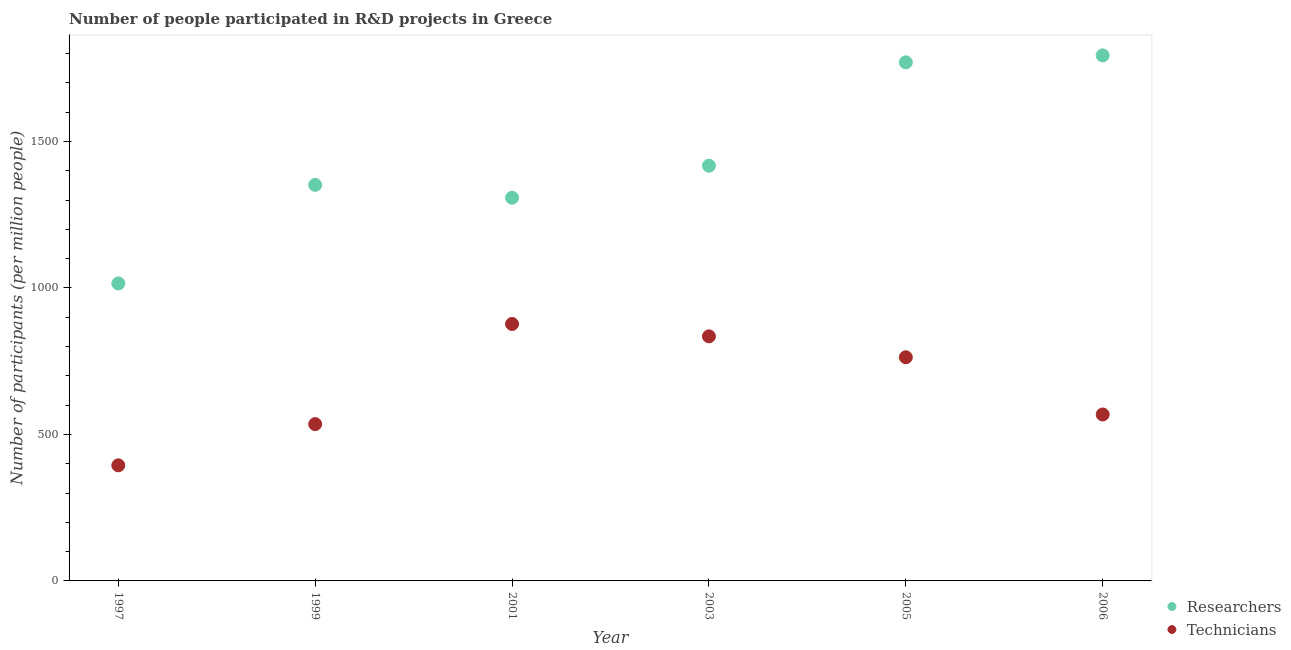Is the number of dotlines equal to the number of legend labels?
Your answer should be very brief. Yes. What is the number of researchers in 2001?
Give a very brief answer. 1307.94. Across all years, what is the maximum number of technicians?
Provide a short and direct response. 877.01. Across all years, what is the minimum number of researchers?
Provide a short and direct response. 1015.39. In which year was the number of researchers maximum?
Your answer should be compact. 2006. What is the total number of technicians in the graph?
Offer a terse response. 3972.89. What is the difference between the number of researchers in 1997 and that in 1999?
Make the answer very short. -336.27. What is the difference between the number of researchers in 2001 and the number of technicians in 1999?
Your answer should be compact. 772.8. What is the average number of technicians per year?
Your answer should be very brief. 662.15. In the year 1997, what is the difference between the number of technicians and number of researchers?
Keep it short and to the point. -620.87. What is the ratio of the number of technicians in 2005 to that in 2006?
Give a very brief answer. 1.34. What is the difference between the highest and the second highest number of researchers?
Provide a succinct answer. 23.75. What is the difference between the highest and the lowest number of researchers?
Your answer should be compact. 778.31. In how many years, is the number of technicians greater than the average number of technicians taken over all years?
Your answer should be compact. 3. Is the sum of the number of researchers in 2001 and 2005 greater than the maximum number of technicians across all years?
Your response must be concise. Yes. How many dotlines are there?
Your answer should be very brief. 2. Are the values on the major ticks of Y-axis written in scientific E-notation?
Your response must be concise. No. Does the graph contain any zero values?
Ensure brevity in your answer.  No. How many legend labels are there?
Make the answer very short. 2. What is the title of the graph?
Ensure brevity in your answer.  Number of people participated in R&D projects in Greece. Does "Secondary Education" appear as one of the legend labels in the graph?
Offer a terse response. No. What is the label or title of the X-axis?
Your answer should be very brief. Year. What is the label or title of the Y-axis?
Your response must be concise. Number of participants (per million people). What is the Number of participants (per million people) in Researchers in 1997?
Make the answer very short. 1015.39. What is the Number of participants (per million people) in Technicians in 1997?
Your answer should be compact. 394.52. What is the Number of participants (per million people) in Researchers in 1999?
Offer a terse response. 1351.66. What is the Number of participants (per million people) in Technicians in 1999?
Make the answer very short. 535.14. What is the Number of participants (per million people) of Researchers in 2001?
Your answer should be very brief. 1307.94. What is the Number of participants (per million people) of Technicians in 2001?
Your answer should be compact. 877.01. What is the Number of participants (per million people) of Researchers in 2003?
Give a very brief answer. 1417.21. What is the Number of participants (per million people) of Technicians in 2003?
Provide a succinct answer. 834.74. What is the Number of participants (per million people) of Researchers in 2005?
Ensure brevity in your answer.  1769.95. What is the Number of participants (per million people) in Technicians in 2005?
Your response must be concise. 763.38. What is the Number of participants (per million people) of Researchers in 2006?
Provide a succinct answer. 1793.7. What is the Number of participants (per million people) in Technicians in 2006?
Offer a very short reply. 568.1. Across all years, what is the maximum Number of participants (per million people) of Researchers?
Provide a succinct answer. 1793.7. Across all years, what is the maximum Number of participants (per million people) of Technicians?
Your answer should be very brief. 877.01. Across all years, what is the minimum Number of participants (per million people) in Researchers?
Provide a short and direct response. 1015.39. Across all years, what is the minimum Number of participants (per million people) in Technicians?
Your answer should be very brief. 394.52. What is the total Number of participants (per million people) of Researchers in the graph?
Your answer should be very brief. 8655.87. What is the total Number of participants (per million people) in Technicians in the graph?
Your answer should be very brief. 3972.89. What is the difference between the Number of participants (per million people) of Researchers in 1997 and that in 1999?
Give a very brief answer. -336.27. What is the difference between the Number of participants (per million people) of Technicians in 1997 and that in 1999?
Your answer should be compact. -140.62. What is the difference between the Number of participants (per million people) in Researchers in 1997 and that in 2001?
Your answer should be very brief. -292.55. What is the difference between the Number of participants (per million people) in Technicians in 1997 and that in 2001?
Provide a succinct answer. -482.49. What is the difference between the Number of participants (per million people) of Researchers in 1997 and that in 2003?
Provide a short and direct response. -401.82. What is the difference between the Number of participants (per million people) in Technicians in 1997 and that in 2003?
Ensure brevity in your answer.  -440.22. What is the difference between the Number of participants (per million people) of Researchers in 1997 and that in 2005?
Give a very brief answer. -754.56. What is the difference between the Number of participants (per million people) in Technicians in 1997 and that in 2005?
Offer a very short reply. -368.86. What is the difference between the Number of participants (per million people) in Researchers in 1997 and that in 2006?
Your answer should be very brief. -778.31. What is the difference between the Number of participants (per million people) of Technicians in 1997 and that in 2006?
Make the answer very short. -173.58. What is the difference between the Number of participants (per million people) of Researchers in 1999 and that in 2001?
Give a very brief answer. 43.72. What is the difference between the Number of participants (per million people) in Technicians in 1999 and that in 2001?
Make the answer very short. -341.87. What is the difference between the Number of participants (per million people) of Researchers in 1999 and that in 2003?
Provide a succinct answer. -65.55. What is the difference between the Number of participants (per million people) of Technicians in 1999 and that in 2003?
Provide a short and direct response. -299.6. What is the difference between the Number of participants (per million people) in Researchers in 1999 and that in 2005?
Ensure brevity in your answer.  -418.29. What is the difference between the Number of participants (per million people) in Technicians in 1999 and that in 2005?
Your response must be concise. -228.24. What is the difference between the Number of participants (per million people) in Researchers in 1999 and that in 2006?
Give a very brief answer. -442.04. What is the difference between the Number of participants (per million people) of Technicians in 1999 and that in 2006?
Your response must be concise. -32.96. What is the difference between the Number of participants (per million people) of Researchers in 2001 and that in 2003?
Your answer should be very brief. -109.27. What is the difference between the Number of participants (per million people) of Technicians in 2001 and that in 2003?
Provide a short and direct response. 42.27. What is the difference between the Number of participants (per million people) of Researchers in 2001 and that in 2005?
Offer a terse response. -462.01. What is the difference between the Number of participants (per million people) in Technicians in 2001 and that in 2005?
Your answer should be compact. 113.63. What is the difference between the Number of participants (per million people) in Researchers in 2001 and that in 2006?
Provide a succinct answer. -485.76. What is the difference between the Number of participants (per million people) in Technicians in 2001 and that in 2006?
Make the answer very short. 308.91. What is the difference between the Number of participants (per million people) of Researchers in 2003 and that in 2005?
Make the answer very short. -352.74. What is the difference between the Number of participants (per million people) in Technicians in 2003 and that in 2005?
Provide a short and direct response. 71.35. What is the difference between the Number of participants (per million people) of Researchers in 2003 and that in 2006?
Your response must be concise. -376.49. What is the difference between the Number of participants (per million people) of Technicians in 2003 and that in 2006?
Offer a terse response. 266.64. What is the difference between the Number of participants (per million people) of Researchers in 2005 and that in 2006?
Provide a short and direct response. -23.75. What is the difference between the Number of participants (per million people) in Technicians in 2005 and that in 2006?
Keep it short and to the point. 195.28. What is the difference between the Number of participants (per million people) of Researchers in 1997 and the Number of participants (per million people) of Technicians in 1999?
Give a very brief answer. 480.25. What is the difference between the Number of participants (per million people) in Researchers in 1997 and the Number of participants (per million people) in Technicians in 2001?
Provide a succinct answer. 138.38. What is the difference between the Number of participants (per million people) in Researchers in 1997 and the Number of participants (per million people) in Technicians in 2003?
Your answer should be very brief. 180.65. What is the difference between the Number of participants (per million people) of Researchers in 1997 and the Number of participants (per million people) of Technicians in 2005?
Your answer should be very brief. 252.01. What is the difference between the Number of participants (per million people) in Researchers in 1997 and the Number of participants (per million people) in Technicians in 2006?
Provide a succinct answer. 447.29. What is the difference between the Number of participants (per million people) of Researchers in 1999 and the Number of participants (per million people) of Technicians in 2001?
Provide a succinct answer. 474.65. What is the difference between the Number of participants (per million people) in Researchers in 1999 and the Number of participants (per million people) in Technicians in 2003?
Your response must be concise. 516.92. What is the difference between the Number of participants (per million people) in Researchers in 1999 and the Number of participants (per million people) in Technicians in 2005?
Ensure brevity in your answer.  588.28. What is the difference between the Number of participants (per million people) of Researchers in 1999 and the Number of participants (per million people) of Technicians in 2006?
Offer a very short reply. 783.56. What is the difference between the Number of participants (per million people) of Researchers in 2001 and the Number of participants (per million people) of Technicians in 2003?
Your answer should be very brief. 473.21. What is the difference between the Number of participants (per million people) of Researchers in 2001 and the Number of participants (per million people) of Technicians in 2005?
Offer a terse response. 544.56. What is the difference between the Number of participants (per million people) of Researchers in 2001 and the Number of participants (per million people) of Technicians in 2006?
Offer a very short reply. 739.84. What is the difference between the Number of participants (per million people) of Researchers in 2003 and the Number of participants (per million people) of Technicians in 2005?
Your response must be concise. 653.83. What is the difference between the Number of participants (per million people) of Researchers in 2003 and the Number of participants (per million people) of Technicians in 2006?
Your response must be concise. 849.11. What is the difference between the Number of participants (per million people) of Researchers in 2005 and the Number of participants (per million people) of Technicians in 2006?
Ensure brevity in your answer.  1201.85. What is the average Number of participants (per million people) of Researchers per year?
Provide a succinct answer. 1442.64. What is the average Number of participants (per million people) in Technicians per year?
Your answer should be compact. 662.15. In the year 1997, what is the difference between the Number of participants (per million people) in Researchers and Number of participants (per million people) in Technicians?
Your answer should be compact. 620.87. In the year 1999, what is the difference between the Number of participants (per million people) in Researchers and Number of participants (per million people) in Technicians?
Your answer should be very brief. 816.52. In the year 2001, what is the difference between the Number of participants (per million people) of Researchers and Number of participants (per million people) of Technicians?
Offer a terse response. 430.93. In the year 2003, what is the difference between the Number of participants (per million people) in Researchers and Number of participants (per million people) in Technicians?
Keep it short and to the point. 582.47. In the year 2005, what is the difference between the Number of participants (per million people) in Researchers and Number of participants (per million people) in Technicians?
Give a very brief answer. 1006.57. In the year 2006, what is the difference between the Number of participants (per million people) of Researchers and Number of participants (per million people) of Technicians?
Keep it short and to the point. 1225.6. What is the ratio of the Number of participants (per million people) of Researchers in 1997 to that in 1999?
Make the answer very short. 0.75. What is the ratio of the Number of participants (per million people) in Technicians in 1997 to that in 1999?
Ensure brevity in your answer.  0.74. What is the ratio of the Number of participants (per million people) in Researchers in 1997 to that in 2001?
Your response must be concise. 0.78. What is the ratio of the Number of participants (per million people) in Technicians in 1997 to that in 2001?
Keep it short and to the point. 0.45. What is the ratio of the Number of participants (per million people) in Researchers in 1997 to that in 2003?
Offer a terse response. 0.72. What is the ratio of the Number of participants (per million people) of Technicians in 1997 to that in 2003?
Keep it short and to the point. 0.47. What is the ratio of the Number of participants (per million people) of Researchers in 1997 to that in 2005?
Offer a terse response. 0.57. What is the ratio of the Number of participants (per million people) of Technicians in 1997 to that in 2005?
Ensure brevity in your answer.  0.52. What is the ratio of the Number of participants (per million people) of Researchers in 1997 to that in 2006?
Your response must be concise. 0.57. What is the ratio of the Number of participants (per million people) of Technicians in 1997 to that in 2006?
Your response must be concise. 0.69. What is the ratio of the Number of participants (per million people) of Researchers in 1999 to that in 2001?
Provide a short and direct response. 1.03. What is the ratio of the Number of participants (per million people) of Technicians in 1999 to that in 2001?
Ensure brevity in your answer.  0.61. What is the ratio of the Number of participants (per million people) in Researchers in 1999 to that in 2003?
Your answer should be very brief. 0.95. What is the ratio of the Number of participants (per million people) in Technicians in 1999 to that in 2003?
Offer a terse response. 0.64. What is the ratio of the Number of participants (per million people) in Researchers in 1999 to that in 2005?
Your answer should be compact. 0.76. What is the ratio of the Number of participants (per million people) of Technicians in 1999 to that in 2005?
Keep it short and to the point. 0.7. What is the ratio of the Number of participants (per million people) in Researchers in 1999 to that in 2006?
Provide a short and direct response. 0.75. What is the ratio of the Number of participants (per million people) in Technicians in 1999 to that in 2006?
Offer a terse response. 0.94. What is the ratio of the Number of participants (per million people) of Researchers in 2001 to that in 2003?
Your answer should be compact. 0.92. What is the ratio of the Number of participants (per million people) of Technicians in 2001 to that in 2003?
Provide a short and direct response. 1.05. What is the ratio of the Number of participants (per million people) in Researchers in 2001 to that in 2005?
Provide a short and direct response. 0.74. What is the ratio of the Number of participants (per million people) of Technicians in 2001 to that in 2005?
Offer a very short reply. 1.15. What is the ratio of the Number of participants (per million people) of Researchers in 2001 to that in 2006?
Offer a very short reply. 0.73. What is the ratio of the Number of participants (per million people) in Technicians in 2001 to that in 2006?
Keep it short and to the point. 1.54. What is the ratio of the Number of participants (per million people) of Researchers in 2003 to that in 2005?
Offer a very short reply. 0.8. What is the ratio of the Number of participants (per million people) of Technicians in 2003 to that in 2005?
Offer a terse response. 1.09. What is the ratio of the Number of participants (per million people) of Researchers in 2003 to that in 2006?
Give a very brief answer. 0.79. What is the ratio of the Number of participants (per million people) of Technicians in 2003 to that in 2006?
Your response must be concise. 1.47. What is the ratio of the Number of participants (per million people) of Technicians in 2005 to that in 2006?
Make the answer very short. 1.34. What is the difference between the highest and the second highest Number of participants (per million people) of Researchers?
Keep it short and to the point. 23.75. What is the difference between the highest and the second highest Number of participants (per million people) of Technicians?
Make the answer very short. 42.27. What is the difference between the highest and the lowest Number of participants (per million people) of Researchers?
Keep it short and to the point. 778.31. What is the difference between the highest and the lowest Number of participants (per million people) in Technicians?
Keep it short and to the point. 482.49. 